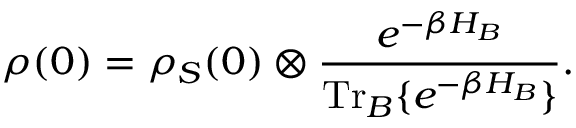<formula> <loc_0><loc_0><loc_500><loc_500>\rho ( 0 ) = \rho _ { S } ( 0 ) \otimes \frac { e ^ { - \beta H _ { B } } } { T r _ { B } \{ e ^ { - \beta H _ { B } } \} } .</formula> 